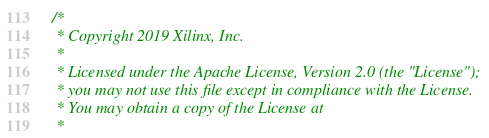Convert code to text. <code><loc_0><loc_0><loc_500><loc_500><_C++_>/*
 * Copyright 2019 Xilinx, Inc.
 *
 * Licensed under the Apache License, Version 2.0 (the "License");
 * you may not use this file except in compliance with the License.
 * You may obtain a copy of the License at
 *</code> 